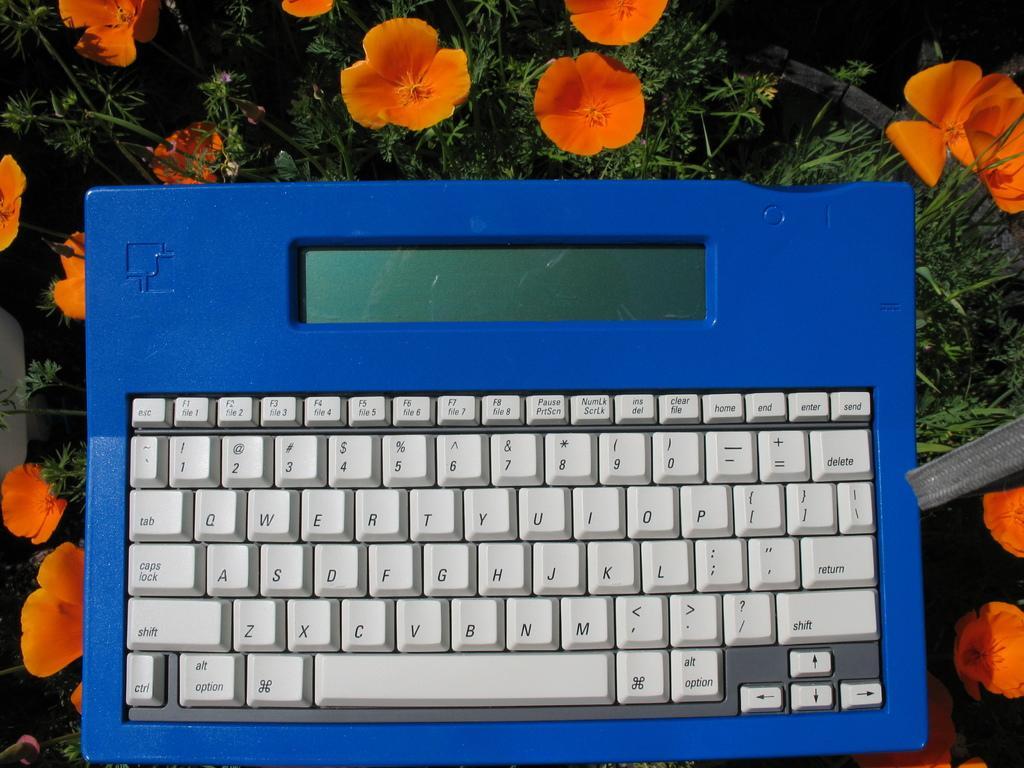Describe this image in one or two sentences. In the center of the image, we can see a keyboard and in the background, there are flowers and plants. 